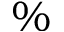<formula> <loc_0><loc_0><loc_500><loc_500>\%</formula> 